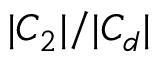<formula> <loc_0><loc_0><loc_500><loc_500>| C _ { 2 } | / | C _ { d } |</formula> 